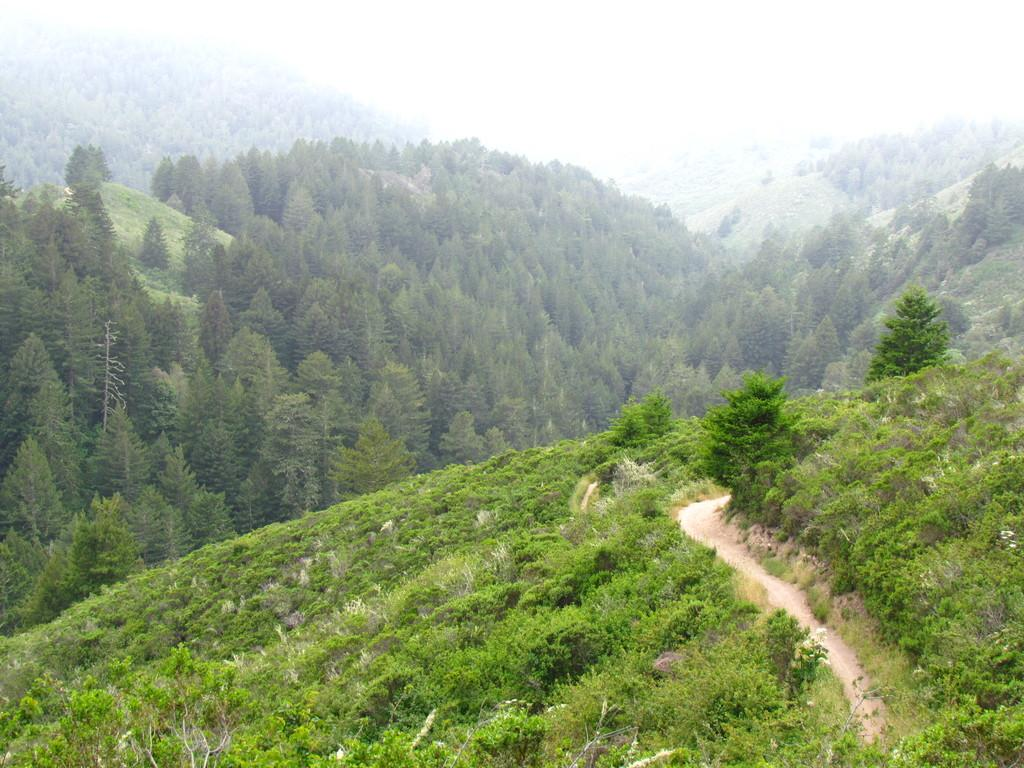What type of natural elements are present in the image? There are trees and plants in the image. Where are the trees and plants located? The trees and plants are on hills. What other geographical features can be seen in the image? There are hills visible in the background of the image. What atmospheric condition is present in the image? Fog is present in the image. Where is the shelf located in the image? There is no shelf present in the image. What type of cactus can be seen growing on the hills in the image? There is no cactus visible in the image; only trees and plants are present on the hills. 